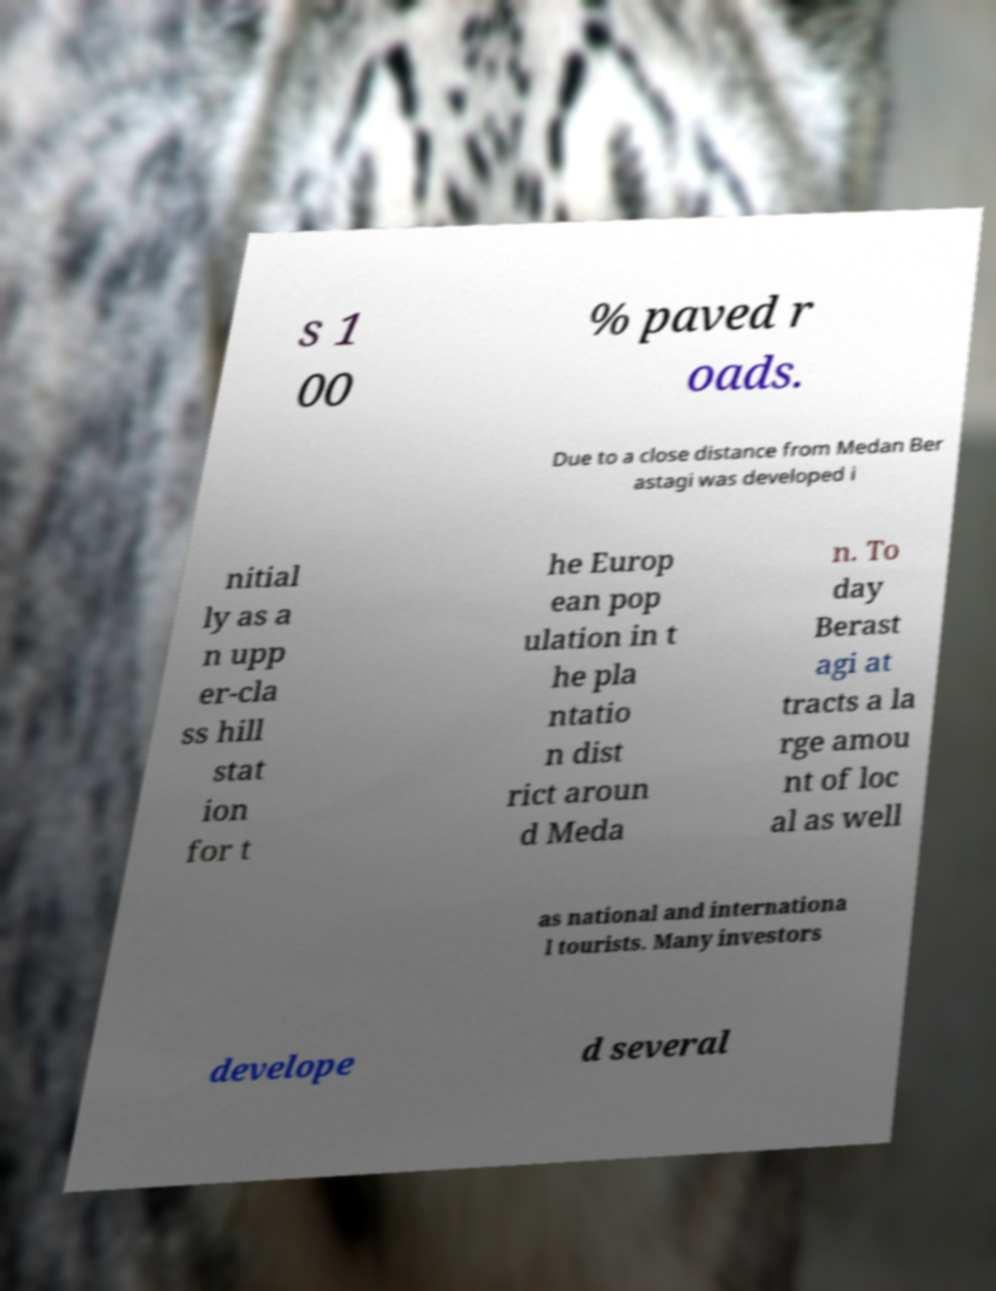Could you extract and type out the text from this image? s 1 00 % paved r oads. Due to a close distance from Medan Ber astagi was developed i nitial ly as a n upp er-cla ss hill stat ion for t he Europ ean pop ulation in t he pla ntatio n dist rict aroun d Meda n. To day Berast agi at tracts a la rge amou nt of loc al as well as national and internationa l tourists. Many investors develope d several 